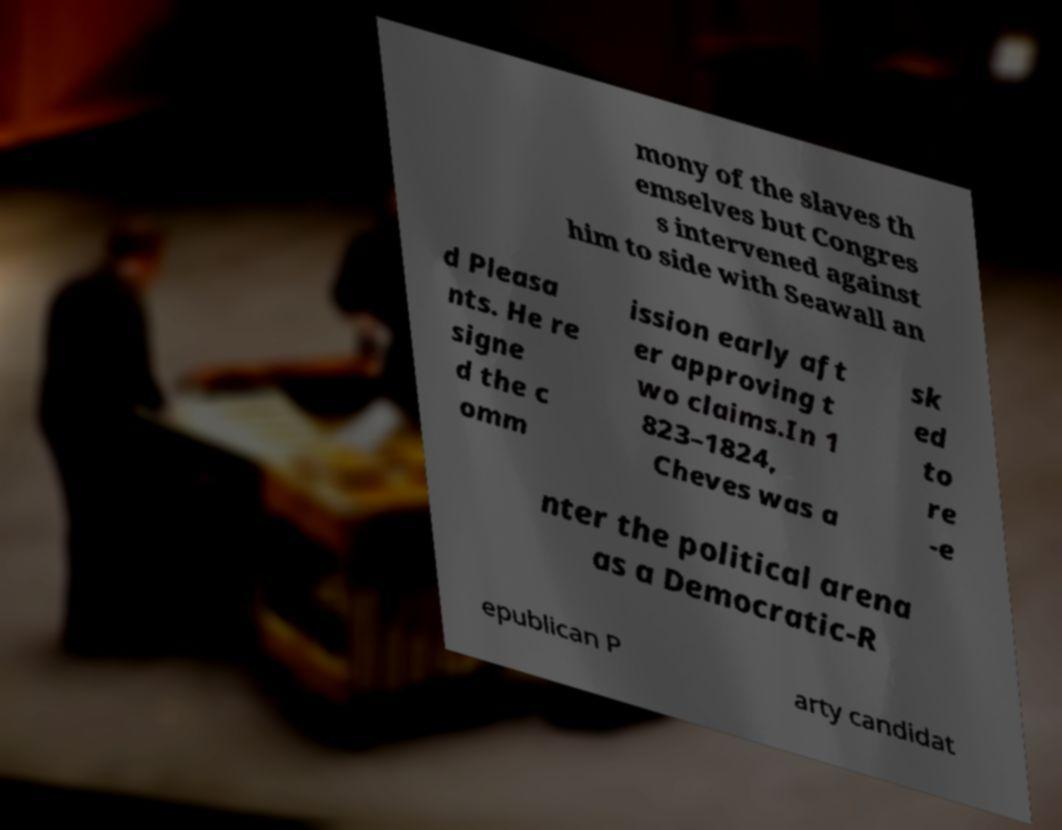There's text embedded in this image that I need extracted. Can you transcribe it verbatim? mony of the slaves th emselves but Congres s intervened against him to side with Seawall an d Pleasa nts. He re signe d the c omm ission early aft er approving t wo claims.In 1 823–1824, Cheves was a sk ed to re -e nter the political arena as a Democratic-R epublican P arty candidat 